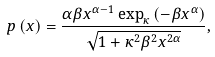<formula> <loc_0><loc_0><loc_500><loc_500>p \left ( x \right ) = \frac { \alpha \beta x ^ { \alpha - 1 } \exp _ { \kappa } \left ( - \beta x ^ { \alpha } \right ) } { \sqrt { 1 + \kappa ^ { 2 } \beta ^ { 2 } x ^ { 2 \alpha } } } ,</formula> 